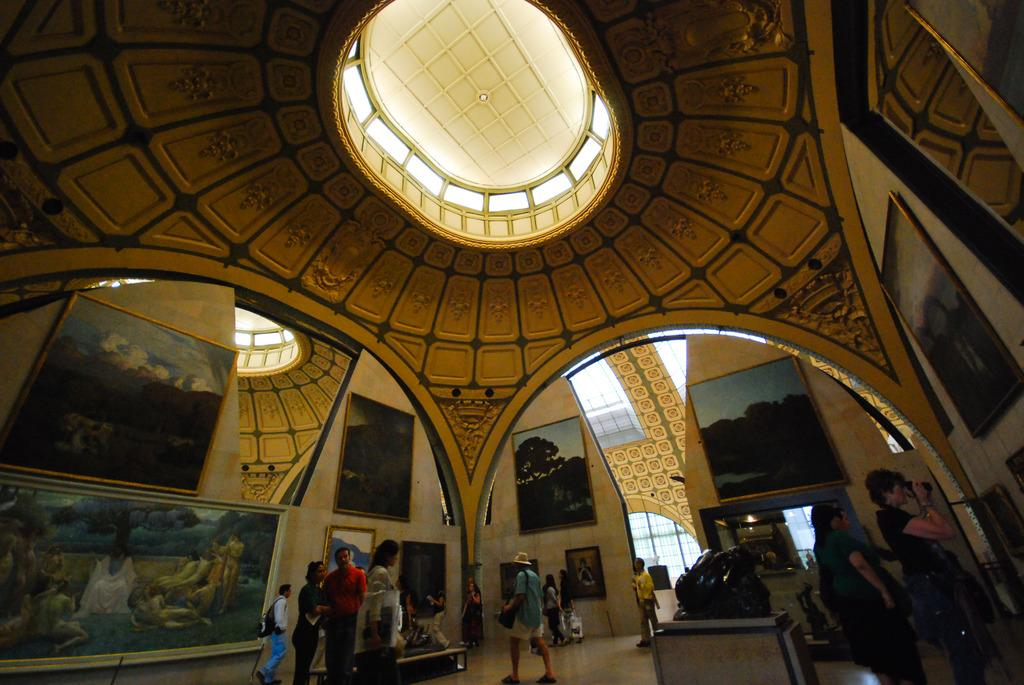What type of location is depicted in the image? The image shows an inside view of a building. What can be seen on the walls in the image? There are photo frames on the walls. What is the surface that the people are standing on? The people are standing on the floor. What degree of education does the nation depicted in the image have? There is no nation depicted in the image, as it shows an inside view of a building. Can you see a quill being used by anyone in the image? There is no quill present in the image. 